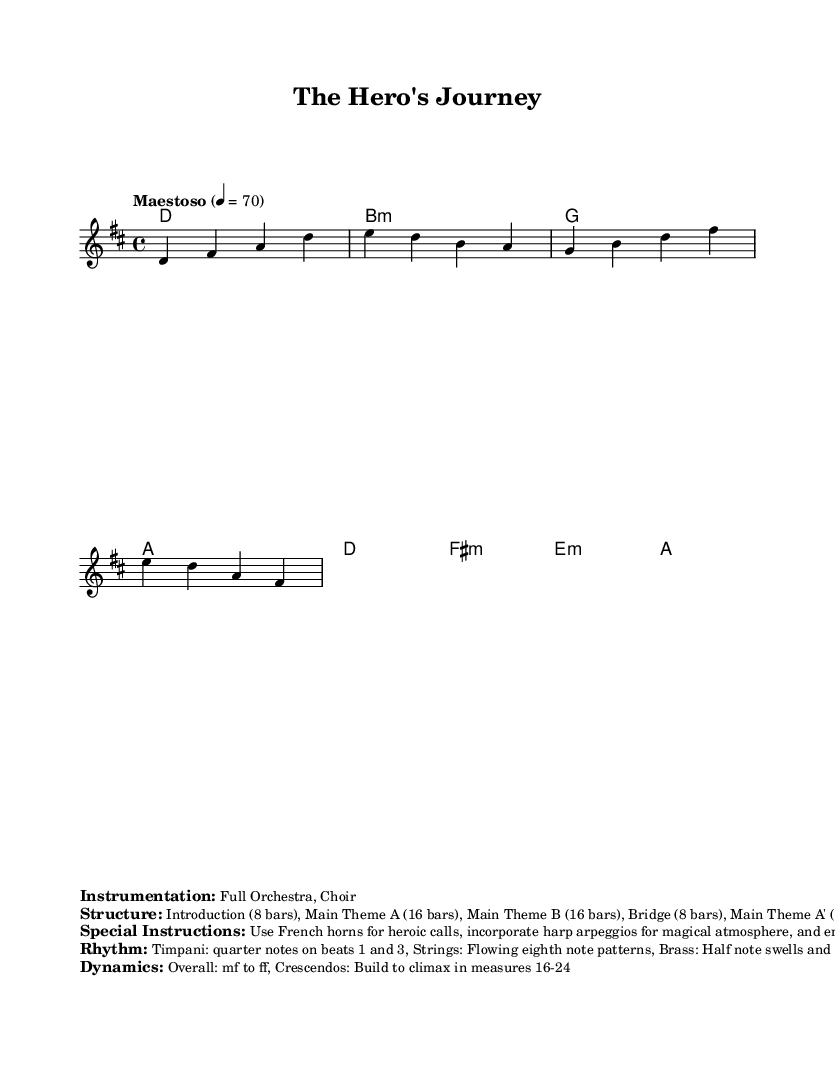What is the key signature of this music? The key signature shows two sharps, which are F# and C#. This identifies the key signature as D major.
Answer: D major What is the time signature of the score? The time signature is indicated at the beginning, showing four beats per measure, thus identifying it as 4/4 time.
Answer: 4/4 What is the tempo marking of the piece? The tempo marking indicates "Maestoso," which is a term used to describe a dignified or stately tempo, denoted by the metronome marking of 70 beats per minute.
Answer: Maestoso What is the structure of the score? The structure is detailed in the marked section, showing that the music is organized into an Introduction, two Main Themes, a Bridge, and a Coda, totaling 72 bars.
Answer: Introduction, Main Theme A, Main Theme B, Bridge, Main Theme A', Coda How many measures are there in the Introduction? The Introduction is specifically marked as containing 8 bars, as stated in the structure section.
Answer: 8 bars What kind of instrumentation is used in this piece? The instrumentation is detailed, indicating that a full orchestra and choir are used, which is typical for epic orchestral scores.
Answer: Full Orchestra, Choir What special instructions are provided for the performance? The score includes special instructions to use French horns for heroic calls and harp arpeggios for a magical atmosphere, enhancing the epic feel.
Answer: Use French horns, harp arpeggios, full choir 